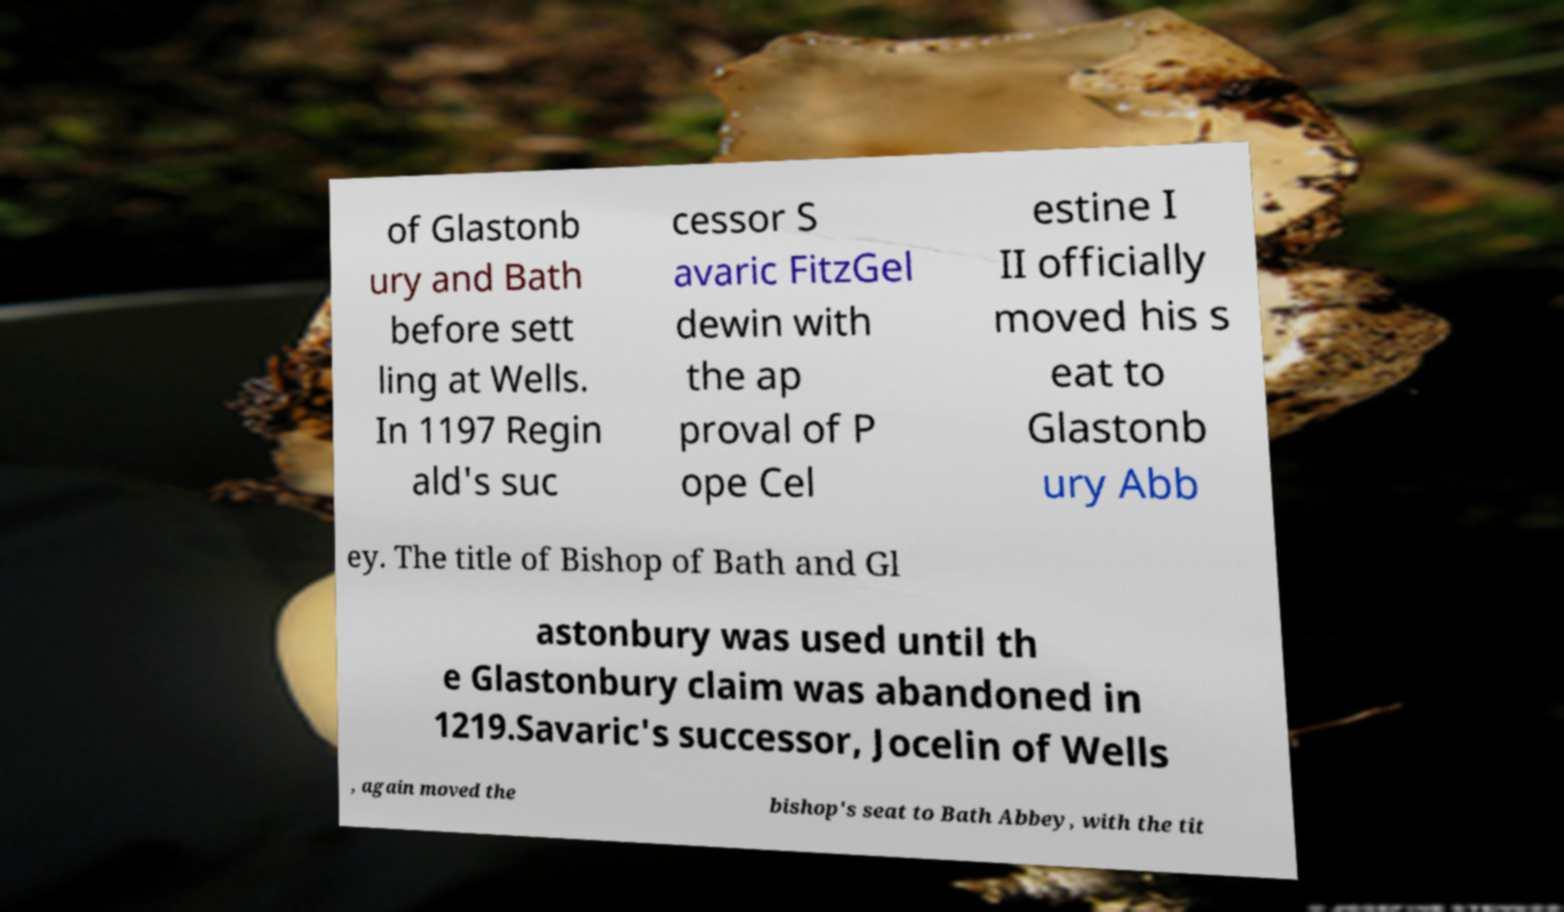What messages or text are displayed in this image? I need them in a readable, typed format. of Glastonb ury and Bath before sett ling at Wells. In 1197 Regin ald's suc cessor S avaric FitzGel dewin with the ap proval of P ope Cel estine I II officially moved his s eat to Glastonb ury Abb ey. The title of Bishop of Bath and Gl astonbury was used until th e Glastonbury claim was abandoned in 1219.Savaric's successor, Jocelin of Wells , again moved the bishop's seat to Bath Abbey, with the tit 